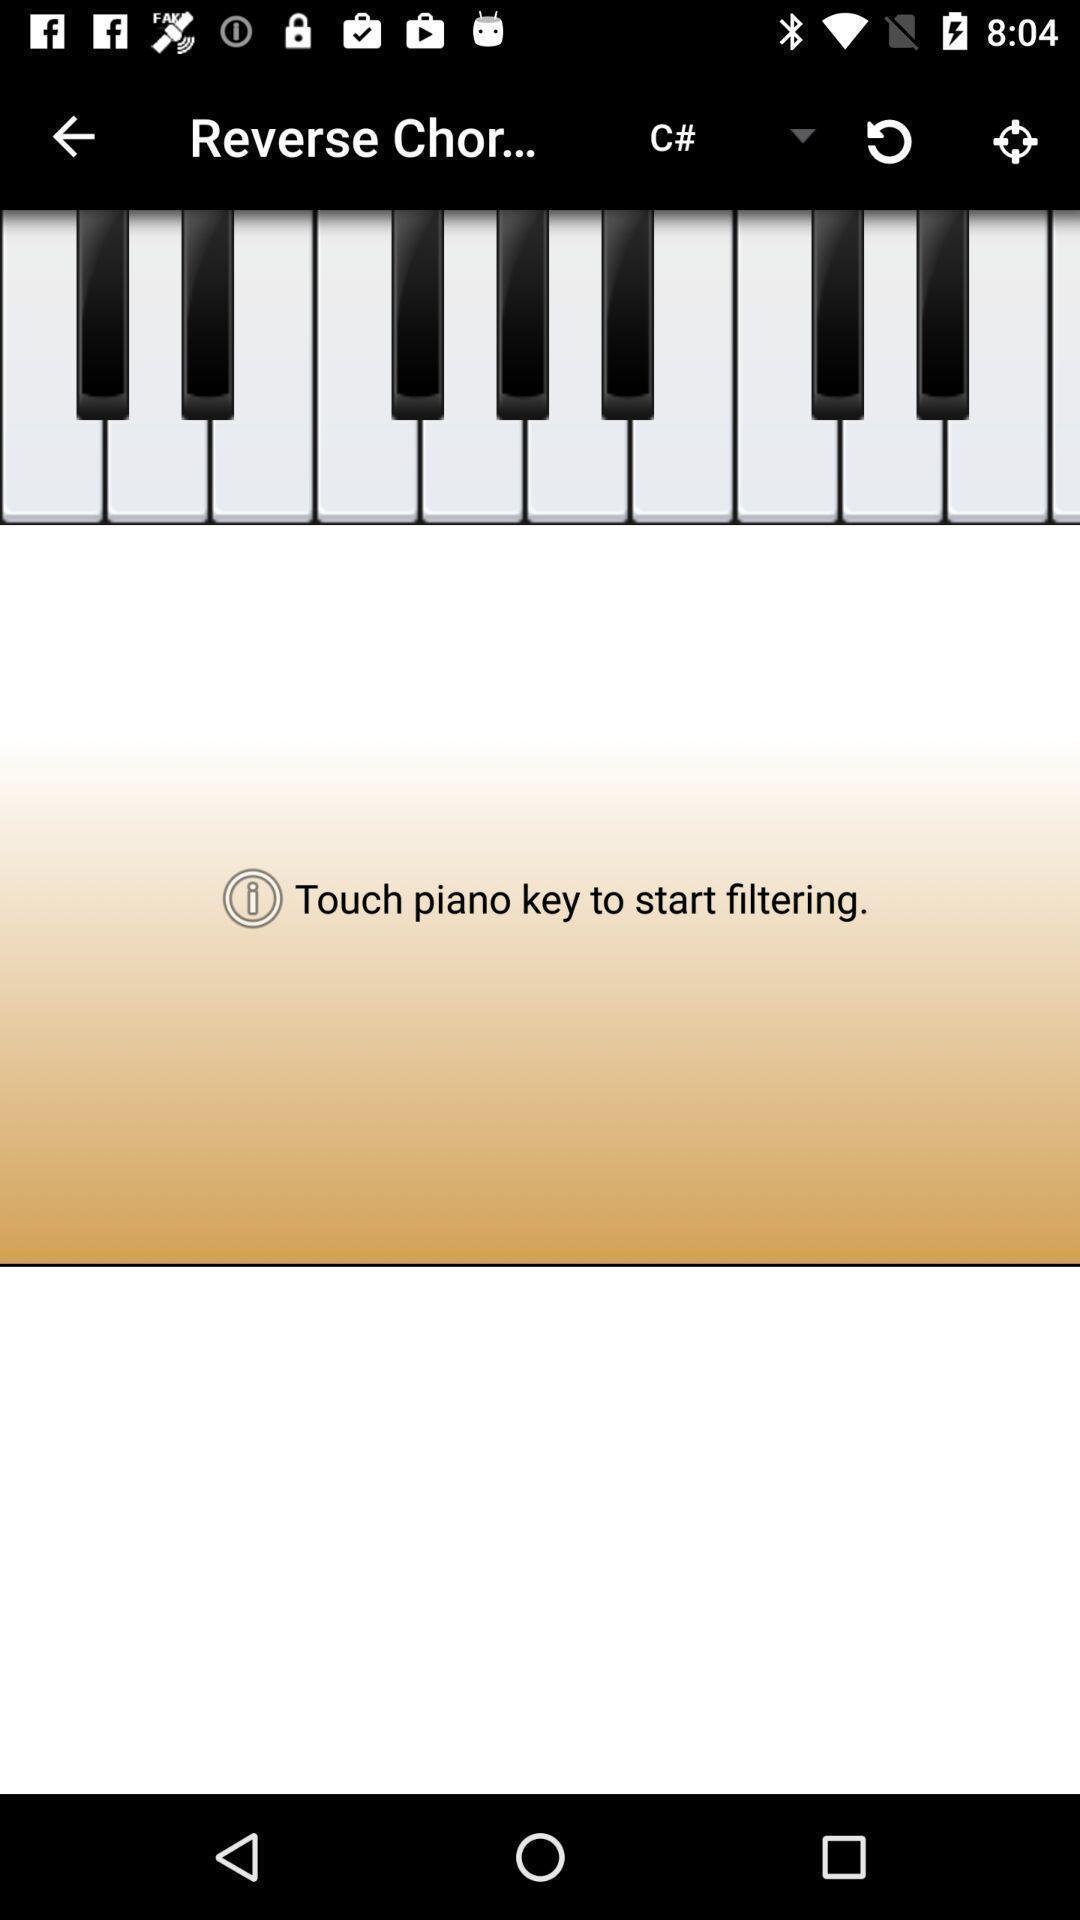Describe the key features of this screenshot. Page showing piano chords on a music theory app. 